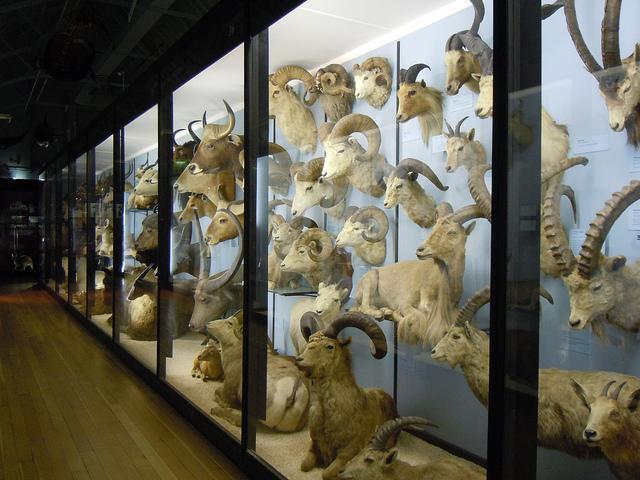How many sheep are visible?
Give a very brief answer. 10. How many cows can you see?
Give a very brief answer. 2. 